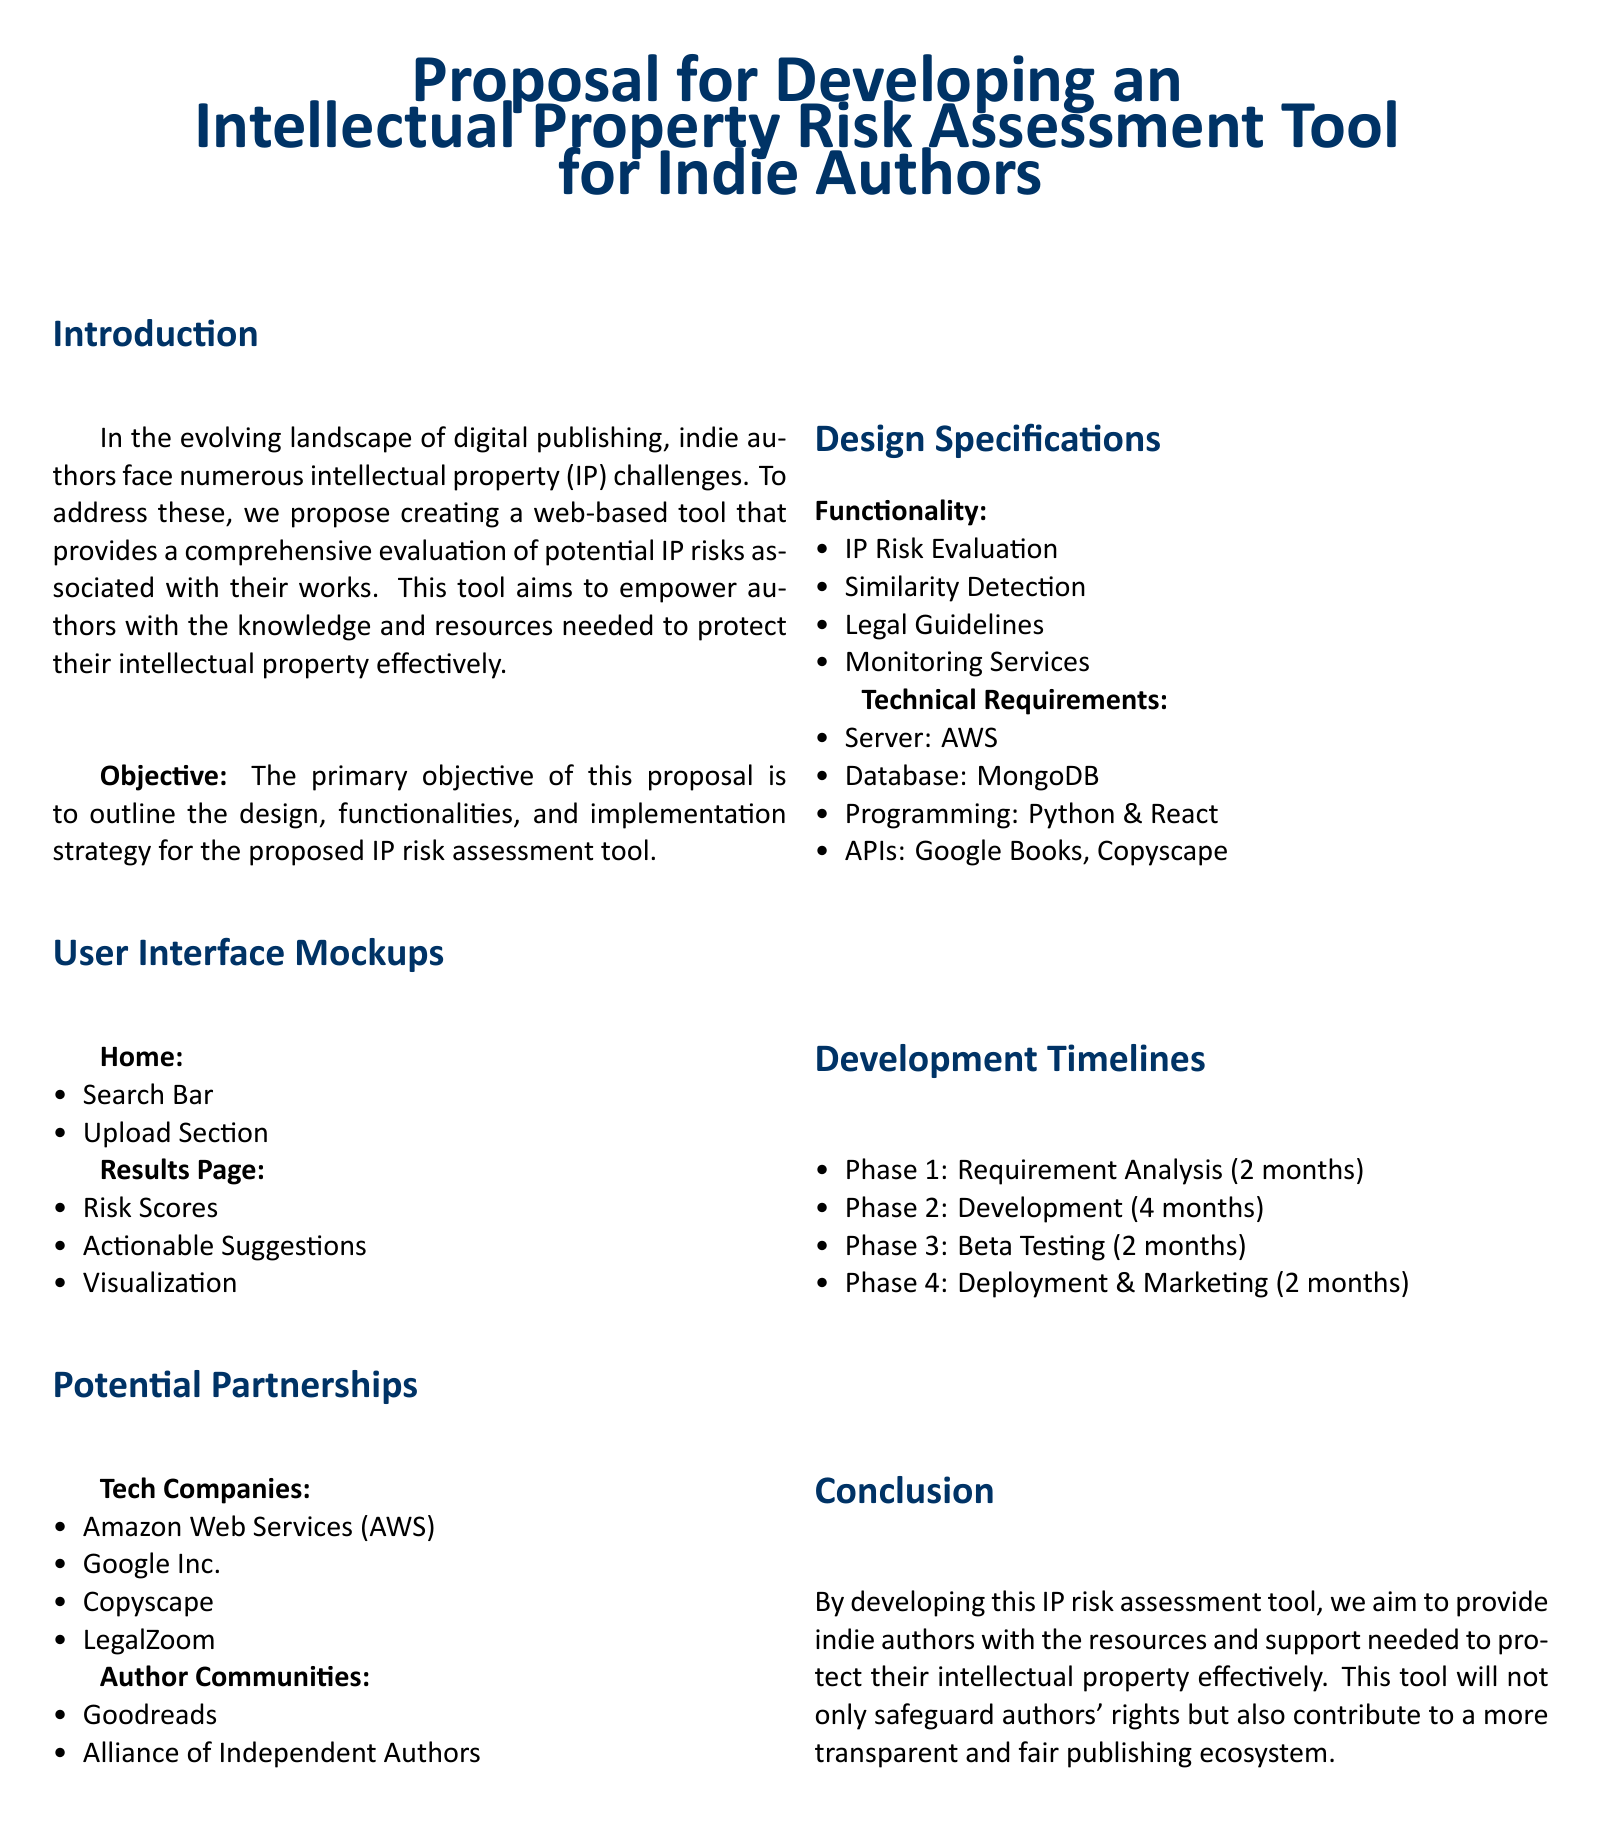What is the title of the proposal? The title of the proposal is clearly stated in the document, which is "Proposal for Developing an Intellectual Property Risk Assessment Tool for Indie Authors."
Answer: Proposal for Developing an Intellectual Property Risk Assessment Tool for Indie Authors How many months is the development phase? The development phase is specifically mentioned as lasting 4 months in the timeline section of the document.
Answer: 4 months Which APIs are mentioned in the technical requirements? The document lists two APIs under technical requirements: Google Books and Copyscape.
Answer: Google Books, Copyscape What is the primary objective of the proposal? The primary objective is outlined in the introduction, focusing on the outline of design, functionalities, and implementation strategy for the proposed tool.
Answer: Outline the design, functionalities, and implementation strategy What is listed as a potential partnership with tech companies? Among the tech companies mentioned, Amazon Web Services (AWS) is explicitly called out as a potential partner in the document.
Answer: Amazon Web Services (AWS) Identify one feature of the user interface mockups. One specific feature of the user interface mockups is the "Search Bar," which is detailed in the Home section.
Answer: Search Bar How many phases are there in the development timeline? The development timeline includes four distinct phases as outlined in the document.
Answer: 4 What organization is listed as part of the author communities? The Alliance of Independent Authors is specified as one of the author communities in the proposed partnerships section.
Answer: Alliance of Independent Authors 